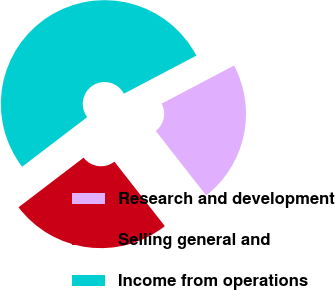<chart> <loc_0><loc_0><loc_500><loc_500><pie_chart><fcel>Research and development<fcel>Selling general and<fcel>Income from operations<nl><fcel>22.14%<fcel>25.19%<fcel>52.66%<nl></chart> 